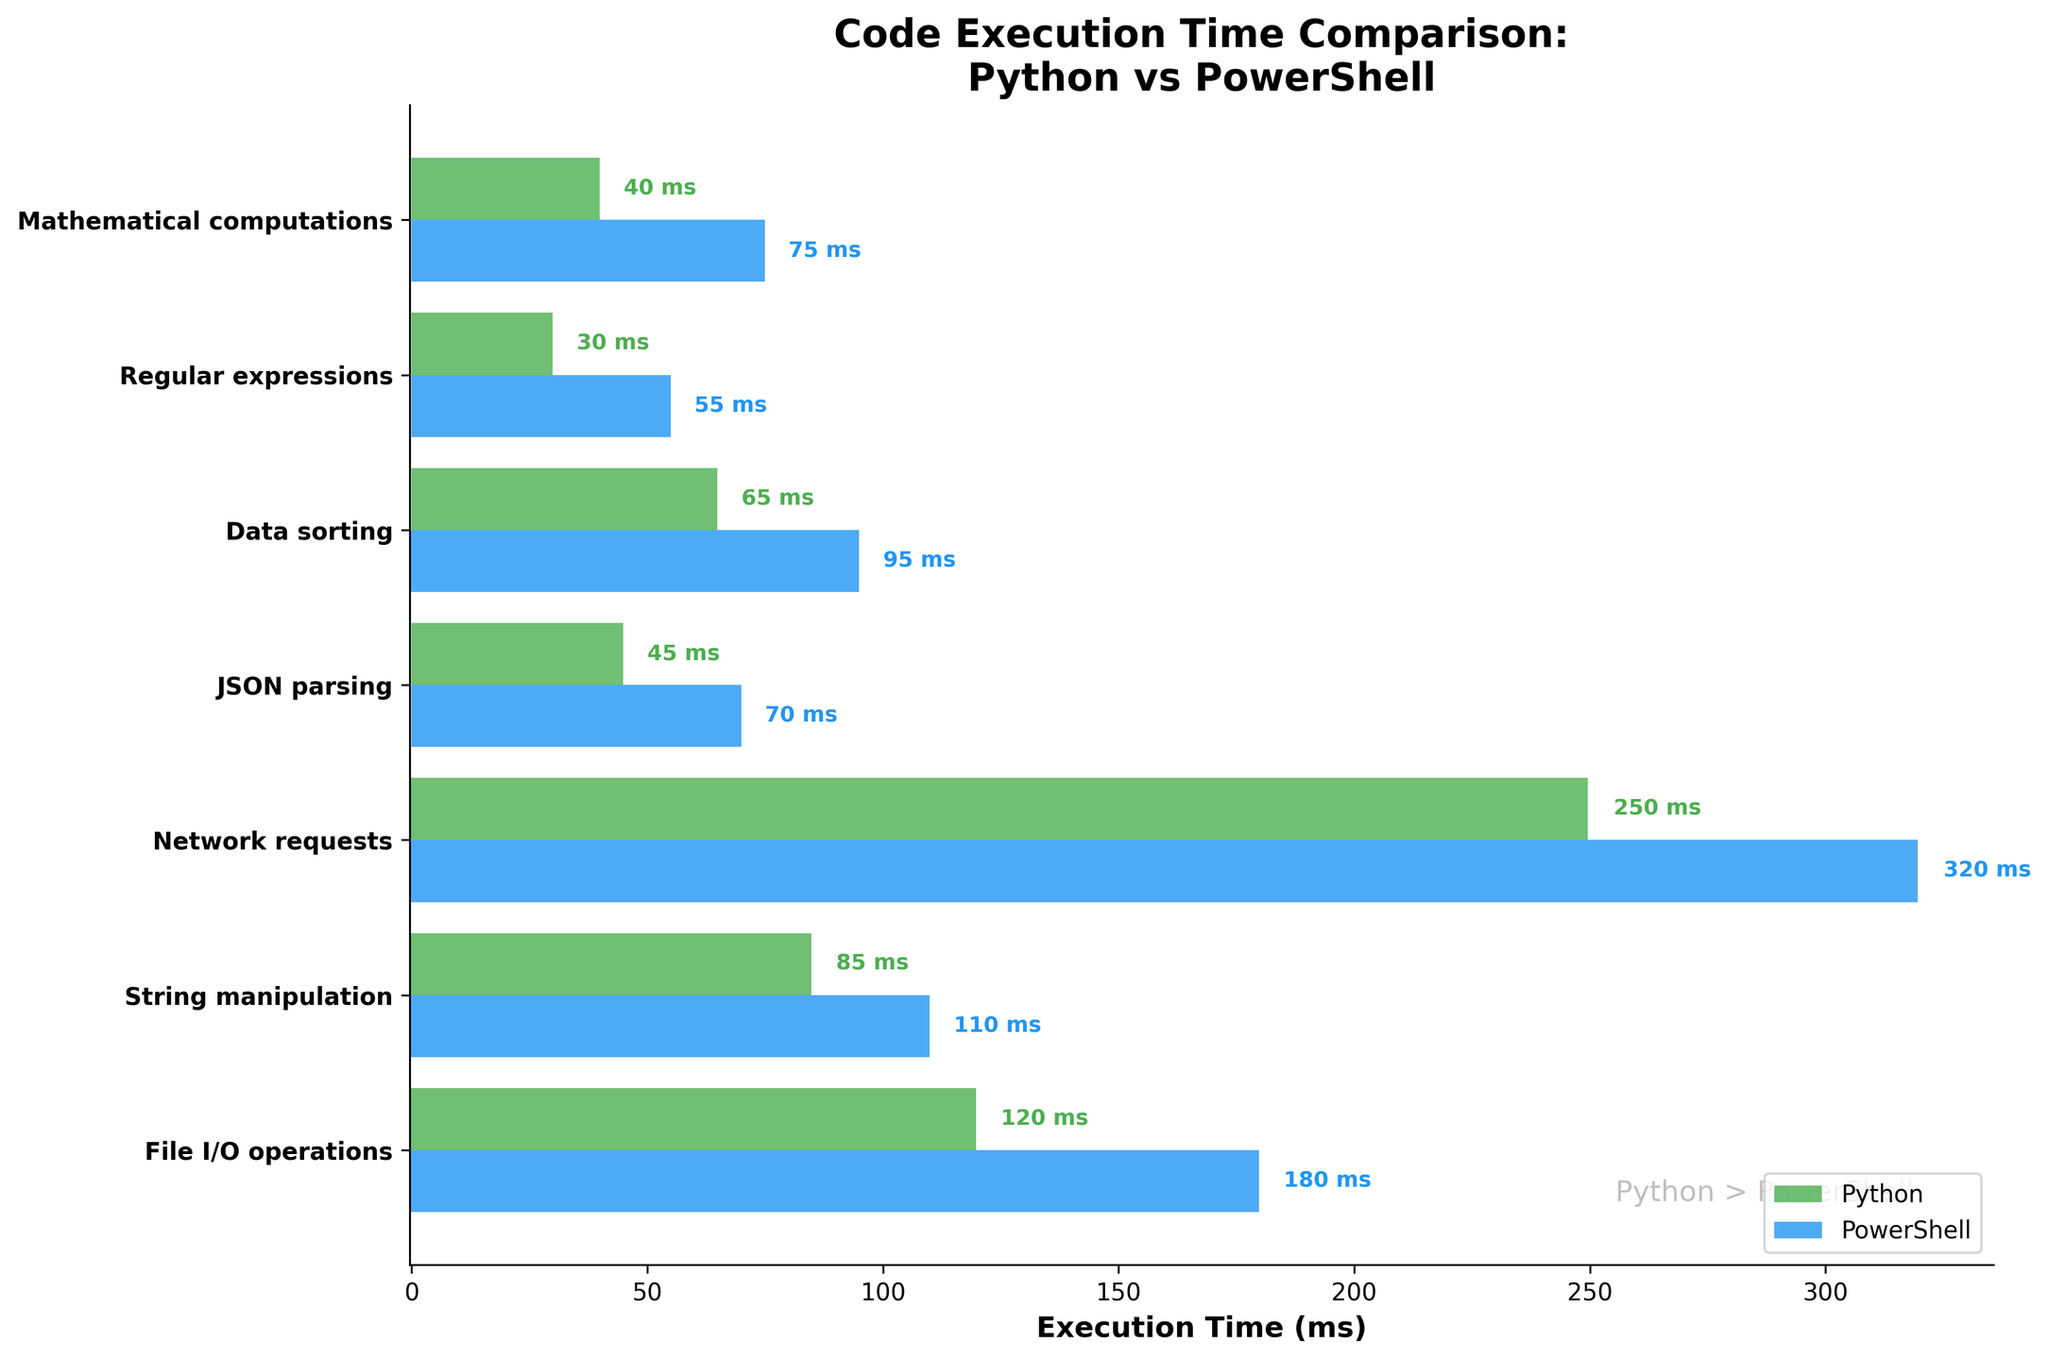Which programming language shows faster execution times for File I/O operations? The figure shows bars for Python and PowerShell execution times for File I/O operations. Python's bar is shorter, indicating 120 ms, while PowerShell's is longer at 180 ms.
Answer: Python How much faster is Python compared to PowerShell for JSON parsing? The execution time for Python is 45 ms, and for PowerShell, it is 70 ms. The difference can be calculated as 70 ms - 45 ms = 25 ms.
Answer: 25 ms Which task has the greatest difference in execution time between Python and PowerShell? The greatest difference can be determined by examining the differences for each task, and the largest difference is found in Network requests (320 ms - 250 ms = 70 ms).
Answer: Network requests What is the average execution time for Python across all tasks? To find the average, sum all execution times for Python (120 + 85 + 250 + 45 + 65 + 30 + 40) and divide by the number of tasks (7). Therefore, the average is (635 / 7 ≈ 90.71 ms).
Answer: ~90.71 ms For how many tasks does Python outperform PowerShell in execution time? By counting the number of bars where Python's bar is shorter than PowerShell's, we see that Python outperforms PowerShell in all 7 tasks.
Answer: 7 Which task has the smallest execution time difference between Python and PowerShell? The smallest execution time difference is found by comparing each task's differences. Regular expressions have the smallest difference where (55 ms - 30 ms = 25 ms).
Answer: Regular expressions What task takes the most time for Python to execute? By looking at the longest bar for Python, we find that Network requests have the highest execution time at 250 ms.
Answer: Network requests Which task shows the smallest execution time for PowerShell? The shortest bar for PowerShell corresponds to Regular expressions with an execution time of 55 ms.
Answer: Regular expressions What do the colors of the bars represent? The green bars represent Python execution times, and the blue bars represent PowerShell execution times.
Answer: Python and PowerShell What is the range of execution times for PowerShell? The range can be found by subtracting the smallest execution time from the largest execution time for PowerShell, i.e., 320 ms (Network requests) - 55 ms (Regular expressions) = 265 ms
Answer: 265 ms 